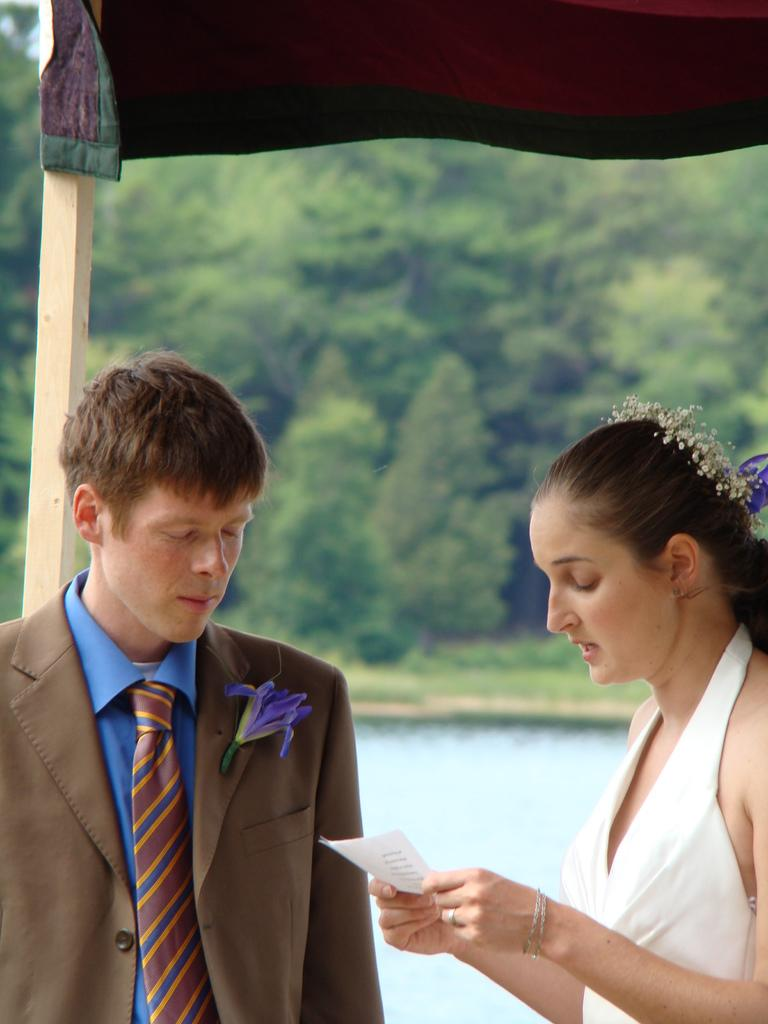How many people are in the image? There are two people in the image. What is visible in the image besides the people? There is water, grass, and trees visible in the image. Can you describe the clothing of the woman on the right side? The woman on the right side is wearing a white dress. What is the woman on the right side holding? The woman on the right side is holding a paper. What direction is the boundary of the water facing in the image? There is no mention of a boundary in the image, and therefore no direction can be determined. 